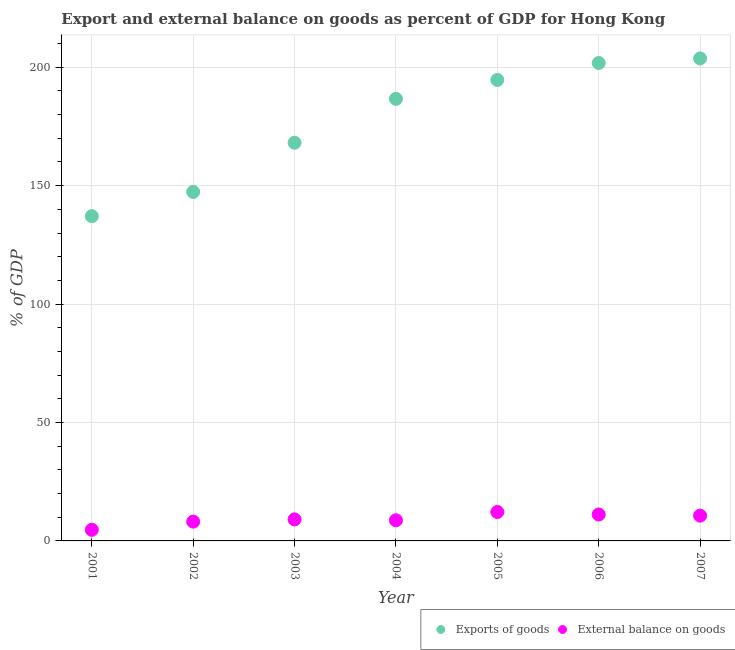What is the export of goods as percentage of gdp in 2002?
Provide a succinct answer. 147.36. Across all years, what is the maximum export of goods as percentage of gdp?
Your answer should be compact. 203.72. Across all years, what is the minimum external balance on goods as percentage of gdp?
Provide a short and direct response. 4.69. In which year was the external balance on goods as percentage of gdp maximum?
Provide a short and direct response. 2005. In which year was the external balance on goods as percentage of gdp minimum?
Your response must be concise. 2001. What is the total export of goods as percentage of gdp in the graph?
Your answer should be compact. 1239.44. What is the difference between the export of goods as percentage of gdp in 2002 and that in 2003?
Your response must be concise. -20.77. What is the difference between the external balance on goods as percentage of gdp in 2001 and the export of goods as percentage of gdp in 2004?
Offer a terse response. -181.96. What is the average export of goods as percentage of gdp per year?
Offer a very short reply. 177.06. In the year 2003, what is the difference between the external balance on goods as percentage of gdp and export of goods as percentage of gdp?
Make the answer very short. -159.03. In how many years, is the external balance on goods as percentage of gdp greater than 30 %?
Offer a terse response. 0. What is the ratio of the export of goods as percentage of gdp in 2005 to that in 2007?
Offer a very short reply. 0.96. Is the difference between the export of goods as percentage of gdp in 2002 and 2005 greater than the difference between the external balance on goods as percentage of gdp in 2002 and 2005?
Offer a very short reply. No. What is the difference between the highest and the second highest export of goods as percentage of gdp?
Offer a terse response. 1.92. What is the difference between the highest and the lowest external balance on goods as percentage of gdp?
Make the answer very short. 7.53. In how many years, is the external balance on goods as percentage of gdp greater than the average external balance on goods as percentage of gdp taken over all years?
Give a very brief answer. 3. Is the sum of the export of goods as percentage of gdp in 2004 and 2005 greater than the maximum external balance on goods as percentage of gdp across all years?
Provide a succinct answer. Yes. How many dotlines are there?
Your response must be concise. 2. How many years are there in the graph?
Your response must be concise. 7. Are the values on the major ticks of Y-axis written in scientific E-notation?
Give a very brief answer. No. How many legend labels are there?
Keep it short and to the point. 2. How are the legend labels stacked?
Offer a very short reply. Horizontal. What is the title of the graph?
Make the answer very short. Export and external balance on goods as percent of GDP for Hong Kong. What is the label or title of the X-axis?
Offer a terse response. Year. What is the label or title of the Y-axis?
Ensure brevity in your answer.  % of GDP. What is the % of GDP in Exports of goods in 2001?
Make the answer very short. 137.12. What is the % of GDP of External balance on goods in 2001?
Your answer should be very brief. 4.69. What is the % of GDP in Exports of goods in 2002?
Your answer should be very brief. 147.36. What is the % of GDP in External balance on goods in 2002?
Provide a succinct answer. 8.16. What is the % of GDP of Exports of goods in 2003?
Make the answer very short. 168.13. What is the % of GDP in External balance on goods in 2003?
Offer a very short reply. 9.1. What is the % of GDP in Exports of goods in 2004?
Keep it short and to the point. 186.65. What is the % of GDP in External balance on goods in 2004?
Give a very brief answer. 8.71. What is the % of GDP of Exports of goods in 2005?
Your answer should be very brief. 194.65. What is the % of GDP in External balance on goods in 2005?
Provide a succinct answer. 12.22. What is the % of GDP in Exports of goods in 2006?
Offer a very short reply. 201.8. What is the % of GDP of External balance on goods in 2006?
Your answer should be compact. 11.16. What is the % of GDP of Exports of goods in 2007?
Make the answer very short. 203.72. What is the % of GDP in External balance on goods in 2007?
Your answer should be very brief. 10.68. Across all years, what is the maximum % of GDP in Exports of goods?
Your answer should be compact. 203.72. Across all years, what is the maximum % of GDP of External balance on goods?
Ensure brevity in your answer.  12.22. Across all years, what is the minimum % of GDP in Exports of goods?
Offer a terse response. 137.12. Across all years, what is the minimum % of GDP in External balance on goods?
Your answer should be very brief. 4.69. What is the total % of GDP of Exports of goods in the graph?
Offer a terse response. 1239.44. What is the total % of GDP in External balance on goods in the graph?
Provide a short and direct response. 64.71. What is the difference between the % of GDP in Exports of goods in 2001 and that in 2002?
Your answer should be very brief. -10.24. What is the difference between the % of GDP in External balance on goods in 2001 and that in 2002?
Keep it short and to the point. -3.47. What is the difference between the % of GDP in Exports of goods in 2001 and that in 2003?
Make the answer very short. -31.01. What is the difference between the % of GDP in External balance on goods in 2001 and that in 2003?
Give a very brief answer. -4.41. What is the difference between the % of GDP of Exports of goods in 2001 and that in 2004?
Your answer should be compact. -49.53. What is the difference between the % of GDP of External balance on goods in 2001 and that in 2004?
Your answer should be compact. -4.02. What is the difference between the % of GDP in Exports of goods in 2001 and that in 2005?
Offer a terse response. -57.53. What is the difference between the % of GDP in External balance on goods in 2001 and that in 2005?
Keep it short and to the point. -7.53. What is the difference between the % of GDP of Exports of goods in 2001 and that in 2006?
Your response must be concise. -64.68. What is the difference between the % of GDP of External balance on goods in 2001 and that in 2006?
Your response must be concise. -6.47. What is the difference between the % of GDP of Exports of goods in 2001 and that in 2007?
Your answer should be very brief. -66.6. What is the difference between the % of GDP in External balance on goods in 2001 and that in 2007?
Keep it short and to the point. -5.98. What is the difference between the % of GDP in Exports of goods in 2002 and that in 2003?
Offer a very short reply. -20.77. What is the difference between the % of GDP of External balance on goods in 2002 and that in 2003?
Your answer should be very brief. -0.94. What is the difference between the % of GDP of Exports of goods in 2002 and that in 2004?
Offer a very short reply. -39.29. What is the difference between the % of GDP of External balance on goods in 2002 and that in 2004?
Your response must be concise. -0.55. What is the difference between the % of GDP in Exports of goods in 2002 and that in 2005?
Give a very brief answer. -47.29. What is the difference between the % of GDP in External balance on goods in 2002 and that in 2005?
Your response must be concise. -4.06. What is the difference between the % of GDP of Exports of goods in 2002 and that in 2006?
Give a very brief answer. -54.44. What is the difference between the % of GDP in External balance on goods in 2002 and that in 2006?
Your answer should be very brief. -3. What is the difference between the % of GDP in Exports of goods in 2002 and that in 2007?
Ensure brevity in your answer.  -56.36. What is the difference between the % of GDP of External balance on goods in 2002 and that in 2007?
Offer a very short reply. -2.52. What is the difference between the % of GDP in Exports of goods in 2003 and that in 2004?
Your response must be concise. -18.52. What is the difference between the % of GDP in External balance on goods in 2003 and that in 2004?
Your answer should be compact. 0.39. What is the difference between the % of GDP of Exports of goods in 2003 and that in 2005?
Keep it short and to the point. -26.52. What is the difference between the % of GDP of External balance on goods in 2003 and that in 2005?
Keep it short and to the point. -3.12. What is the difference between the % of GDP of Exports of goods in 2003 and that in 2006?
Make the answer very short. -33.67. What is the difference between the % of GDP of External balance on goods in 2003 and that in 2006?
Your response must be concise. -2.06. What is the difference between the % of GDP in Exports of goods in 2003 and that in 2007?
Your answer should be compact. -35.59. What is the difference between the % of GDP in External balance on goods in 2003 and that in 2007?
Your response must be concise. -1.58. What is the difference between the % of GDP in Exports of goods in 2004 and that in 2005?
Make the answer very short. -8. What is the difference between the % of GDP of External balance on goods in 2004 and that in 2005?
Your answer should be compact. -3.51. What is the difference between the % of GDP of Exports of goods in 2004 and that in 2006?
Offer a terse response. -15.15. What is the difference between the % of GDP in External balance on goods in 2004 and that in 2006?
Provide a succinct answer. -2.45. What is the difference between the % of GDP in Exports of goods in 2004 and that in 2007?
Keep it short and to the point. -17.07. What is the difference between the % of GDP in External balance on goods in 2004 and that in 2007?
Offer a very short reply. -1.96. What is the difference between the % of GDP of Exports of goods in 2005 and that in 2006?
Ensure brevity in your answer.  -7.15. What is the difference between the % of GDP of External balance on goods in 2005 and that in 2006?
Provide a short and direct response. 1.05. What is the difference between the % of GDP in Exports of goods in 2005 and that in 2007?
Ensure brevity in your answer.  -9.07. What is the difference between the % of GDP of External balance on goods in 2005 and that in 2007?
Offer a very short reply. 1.54. What is the difference between the % of GDP of Exports of goods in 2006 and that in 2007?
Your answer should be compact. -1.92. What is the difference between the % of GDP in External balance on goods in 2006 and that in 2007?
Your answer should be compact. 0.49. What is the difference between the % of GDP in Exports of goods in 2001 and the % of GDP in External balance on goods in 2002?
Offer a very short reply. 128.96. What is the difference between the % of GDP in Exports of goods in 2001 and the % of GDP in External balance on goods in 2003?
Offer a very short reply. 128.02. What is the difference between the % of GDP of Exports of goods in 2001 and the % of GDP of External balance on goods in 2004?
Your answer should be very brief. 128.41. What is the difference between the % of GDP in Exports of goods in 2001 and the % of GDP in External balance on goods in 2005?
Keep it short and to the point. 124.91. What is the difference between the % of GDP in Exports of goods in 2001 and the % of GDP in External balance on goods in 2006?
Your response must be concise. 125.96. What is the difference between the % of GDP of Exports of goods in 2001 and the % of GDP of External balance on goods in 2007?
Provide a succinct answer. 126.45. What is the difference between the % of GDP of Exports of goods in 2002 and the % of GDP of External balance on goods in 2003?
Offer a very short reply. 138.27. What is the difference between the % of GDP in Exports of goods in 2002 and the % of GDP in External balance on goods in 2004?
Make the answer very short. 138.65. What is the difference between the % of GDP in Exports of goods in 2002 and the % of GDP in External balance on goods in 2005?
Your response must be concise. 135.15. What is the difference between the % of GDP in Exports of goods in 2002 and the % of GDP in External balance on goods in 2006?
Offer a terse response. 136.2. What is the difference between the % of GDP in Exports of goods in 2002 and the % of GDP in External balance on goods in 2007?
Your answer should be very brief. 136.69. What is the difference between the % of GDP of Exports of goods in 2003 and the % of GDP of External balance on goods in 2004?
Your answer should be very brief. 159.42. What is the difference between the % of GDP in Exports of goods in 2003 and the % of GDP in External balance on goods in 2005?
Ensure brevity in your answer.  155.91. What is the difference between the % of GDP in Exports of goods in 2003 and the % of GDP in External balance on goods in 2006?
Provide a succinct answer. 156.97. What is the difference between the % of GDP of Exports of goods in 2003 and the % of GDP of External balance on goods in 2007?
Ensure brevity in your answer.  157.46. What is the difference between the % of GDP in Exports of goods in 2004 and the % of GDP in External balance on goods in 2005?
Keep it short and to the point. 174.44. What is the difference between the % of GDP in Exports of goods in 2004 and the % of GDP in External balance on goods in 2006?
Make the answer very short. 175.49. What is the difference between the % of GDP in Exports of goods in 2004 and the % of GDP in External balance on goods in 2007?
Your answer should be compact. 175.98. What is the difference between the % of GDP in Exports of goods in 2005 and the % of GDP in External balance on goods in 2006?
Your response must be concise. 183.49. What is the difference between the % of GDP of Exports of goods in 2005 and the % of GDP of External balance on goods in 2007?
Offer a terse response. 183.98. What is the difference between the % of GDP in Exports of goods in 2006 and the % of GDP in External balance on goods in 2007?
Make the answer very short. 191.13. What is the average % of GDP in Exports of goods per year?
Ensure brevity in your answer.  177.06. What is the average % of GDP of External balance on goods per year?
Your answer should be very brief. 9.24. In the year 2001, what is the difference between the % of GDP of Exports of goods and % of GDP of External balance on goods?
Your answer should be compact. 132.43. In the year 2002, what is the difference between the % of GDP in Exports of goods and % of GDP in External balance on goods?
Ensure brevity in your answer.  139.21. In the year 2003, what is the difference between the % of GDP in Exports of goods and % of GDP in External balance on goods?
Your answer should be very brief. 159.03. In the year 2004, what is the difference between the % of GDP of Exports of goods and % of GDP of External balance on goods?
Offer a very short reply. 177.94. In the year 2005, what is the difference between the % of GDP of Exports of goods and % of GDP of External balance on goods?
Keep it short and to the point. 182.44. In the year 2006, what is the difference between the % of GDP in Exports of goods and % of GDP in External balance on goods?
Make the answer very short. 190.64. In the year 2007, what is the difference between the % of GDP of Exports of goods and % of GDP of External balance on goods?
Offer a terse response. 193.05. What is the ratio of the % of GDP of Exports of goods in 2001 to that in 2002?
Your response must be concise. 0.93. What is the ratio of the % of GDP of External balance on goods in 2001 to that in 2002?
Your answer should be compact. 0.57. What is the ratio of the % of GDP in Exports of goods in 2001 to that in 2003?
Offer a terse response. 0.82. What is the ratio of the % of GDP of External balance on goods in 2001 to that in 2003?
Give a very brief answer. 0.52. What is the ratio of the % of GDP of Exports of goods in 2001 to that in 2004?
Provide a short and direct response. 0.73. What is the ratio of the % of GDP in External balance on goods in 2001 to that in 2004?
Your answer should be compact. 0.54. What is the ratio of the % of GDP of Exports of goods in 2001 to that in 2005?
Your answer should be very brief. 0.7. What is the ratio of the % of GDP of External balance on goods in 2001 to that in 2005?
Keep it short and to the point. 0.38. What is the ratio of the % of GDP in Exports of goods in 2001 to that in 2006?
Your answer should be very brief. 0.68. What is the ratio of the % of GDP of External balance on goods in 2001 to that in 2006?
Ensure brevity in your answer.  0.42. What is the ratio of the % of GDP of Exports of goods in 2001 to that in 2007?
Ensure brevity in your answer.  0.67. What is the ratio of the % of GDP in External balance on goods in 2001 to that in 2007?
Give a very brief answer. 0.44. What is the ratio of the % of GDP in Exports of goods in 2002 to that in 2003?
Provide a succinct answer. 0.88. What is the ratio of the % of GDP in External balance on goods in 2002 to that in 2003?
Offer a very short reply. 0.9. What is the ratio of the % of GDP of Exports of goods in 2002 to that in 2004?
Offer a very short reply. 0.79. What is the ratio of the % of GDP of External balance on goods in 2002 to that in 2004?
Ensure brevity in your answer.  0.94. What is the ratio of the % of GDP in Exports of goods in 2002 to that in 2005?
Ensure brevity in your answer.  0.76. What is the ratio of the % of GDP of External balance on goods in 2002 to that in 2005?
Ensure brevity in your answer.  0.67. What is the ratio of the % of GDP of Exports of goods in 2002 to that in 2006?
Give a very brief answer. 0.73. What is the ratio of the % of GDP in External balance on goods in 2002 to that in 2006?
Offer a terse response. 0.73. What is the ratio of the % of GDP of Exports of goods in 2002 to that in 2007?
Your answer should be compact. 0.72. What is the ratio of the % of GDP of External balance on goods in 2002 to that in 2007?
Give a very brief answer. 0.76. What is the ratio of the % of GDP of Exports of goods in 2003 to that in 2004?
Provide a succinct answer. 0.9. What is the ratio of the % of GDP of External balance on goods in 2003 to that in 2004?
Provide a short and direct response. 1.04. What is the ratio of the % of GDP of Exports of goods in 2003 to that in 2005?
Offer a terse response. 0.86. What is the ratio of the % of GDP in External balance on goods in 2003 to that in 2005?
Make the answer very short. 0.74. What is the ratio of the % of GDP in Exports of goods in 2003 to that in 2006?
Your answer should be compact. 0.83. What is the ratio of the % of GDP of External balance on goods in 2003 to that in 2006?
Make the answer very short. 0.81. What is the ratio of the % of GDP in Exports of goods in 2003 to that in 2007?
Ensure brevity in your answer.  0.83. What is the ratio of the % of GDP in External balance on goods in 2003 to that in 2007?
Your answer should be compact. 0.85. What is the ratio of the % of GDP of Exports of goods in 2004 to that in 2005?
Offer a terse response. 0.96. What is the ratio of the % of GDP of External balance on goods in 2004 to that in 2005?
Give a very brief answer. 0.71. What is the ratio of the % of GDP of Exports of goods in 2004 to that in 2006?
Your response must be concise. 0.92. What is the ratio of the % of GDP in External balance on goods in 2004 to that in 2006?
Keep it short and to the point. 0.78. What is the ratio of the % of GDP in Exports of goods in 2004 to that in 2007?
Keep it short and to the point. 0.92. What is the ratio of the % of GDP of External balance on goods in 2004 to that in 2007?
Provide a short and direct response. 0.82. What is the ratio of the % of GDP of Exports of goods in 2005 to that in 2006?
Provide a succinct answer. 0.96. What is the ratio of the % of GDP in External balance on goods in 2005 to that in 2006?
Give a very brief answer. 1.09. What is the ratio of the % of GDP in Exports of goods in 2005 to that in 2007?
Keep it short and to the point. 0.96. What is the ratio of the % of GDP of External balance on goods in 2005 to that in 2007?
Provide a short and direct response. 1.14. What is the ratio of the % of GDP in Exports of goods in 2006 to that in 2007?
Provide a succinct answer. 0.99. What is the ratio of the % of GDP in External balance on goods in 2006 to that in 2007?
Offer a very short reply. 1.05. What is the difference between the highest and the second highest % of GDP of Exports of goods?
Your answer should be compact. 1.92. What is the difference between the highest and the second highest % of GDP in External balance on goods?
Provide a short and direct response. 1.05. What is the difference between the highest and the lowest % of GDP of Exports of goods?
Make the answer very short. 66.6. What is the difference between the highest and the lowest % of GDP in External balance on goods?
Provide a short and direct response. 7.53. 